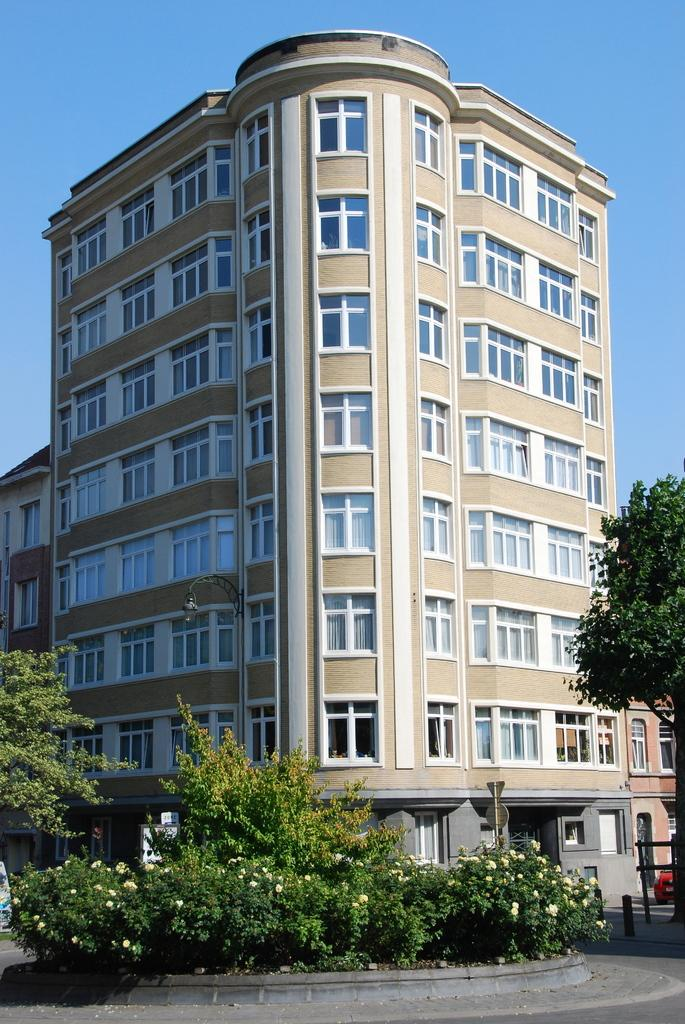What type of vegetation can be seen in the image? There are plants and trees in the image. What structure is located in the middle of the image? There is a building in the middle of the image. What is visible at the top of the image? The sky is visible at the top of the image. What type of pen is being used to write on the trees in the image? There is no pen or writing on the trees in the image. What time of day is it in the image, considering it's an afternoon scene? The time of day cannot be determined from the image, as there are no specific indicators of time. 